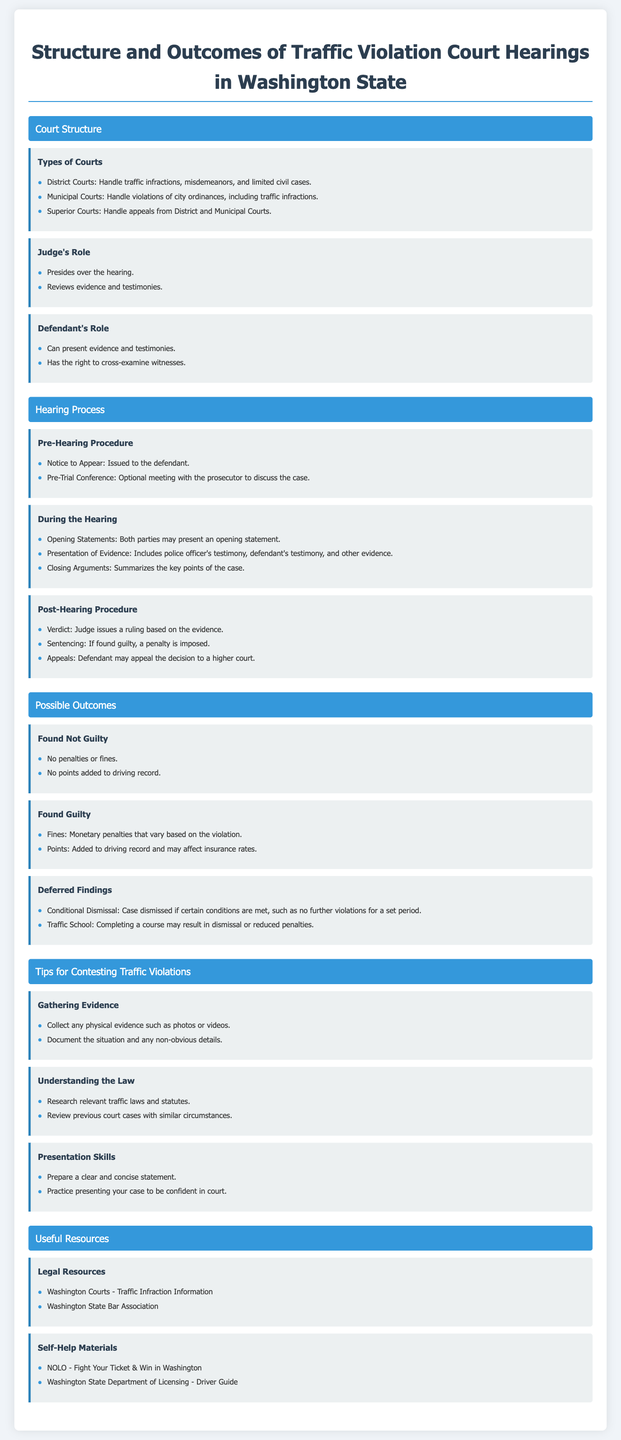what types of courts handle traffic infractions? The document lists District Courts and Municipal Courts as the types of courts handling traffic infractions.
Answer: District Courts, Municipal Courts what are the roles of the judge in a traffic court hearing? The roles of the judge include presiding over the hearing and reviewing evidence and testimonies.
Answer: Presides over the hearing, reviews evidence what is a possible outcome if found not guilty? The document indicates that being found not guilty results in no penalties or fines.
Answer: No penalties or fines what can a defendant do during the hearing? Defendants can present evidence and testimonies, as well as cross-examine witnesses.
Answer: Present evidence, cross-examine witnesses what happens during the post-hearing procedure? The judge issues a verdict and may impose a sentencing if found guilty, with the possibility for appeals.
Answer: Verdict, sentencing, appeals what is a reason for collecting evidence before a hearing? Collecting evidence such as photos or videos can support the defendant's case in court.
Answer: Support the case what is a resource for self-help materials mentioned in the document? The document lists NOLO - Fight Your Ticket & Win in Washington as a self-help resource.
Answer: NOLO - Fight Your Ticket & Win in Washington how can a defendant achieve deferred findings? Conditional dismissal or completing traffic school can lead to deferred findings.
Answer: Conditional dismissal, traffic school what types of evidence may be presented during the hearing? The hearing allows for the presentation of police officer's and defendant's testimony as well as other evidence.
Answer: Police officer's testimony, defendant's testimony, other evidence 